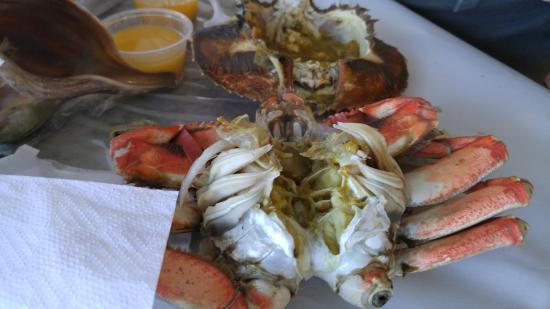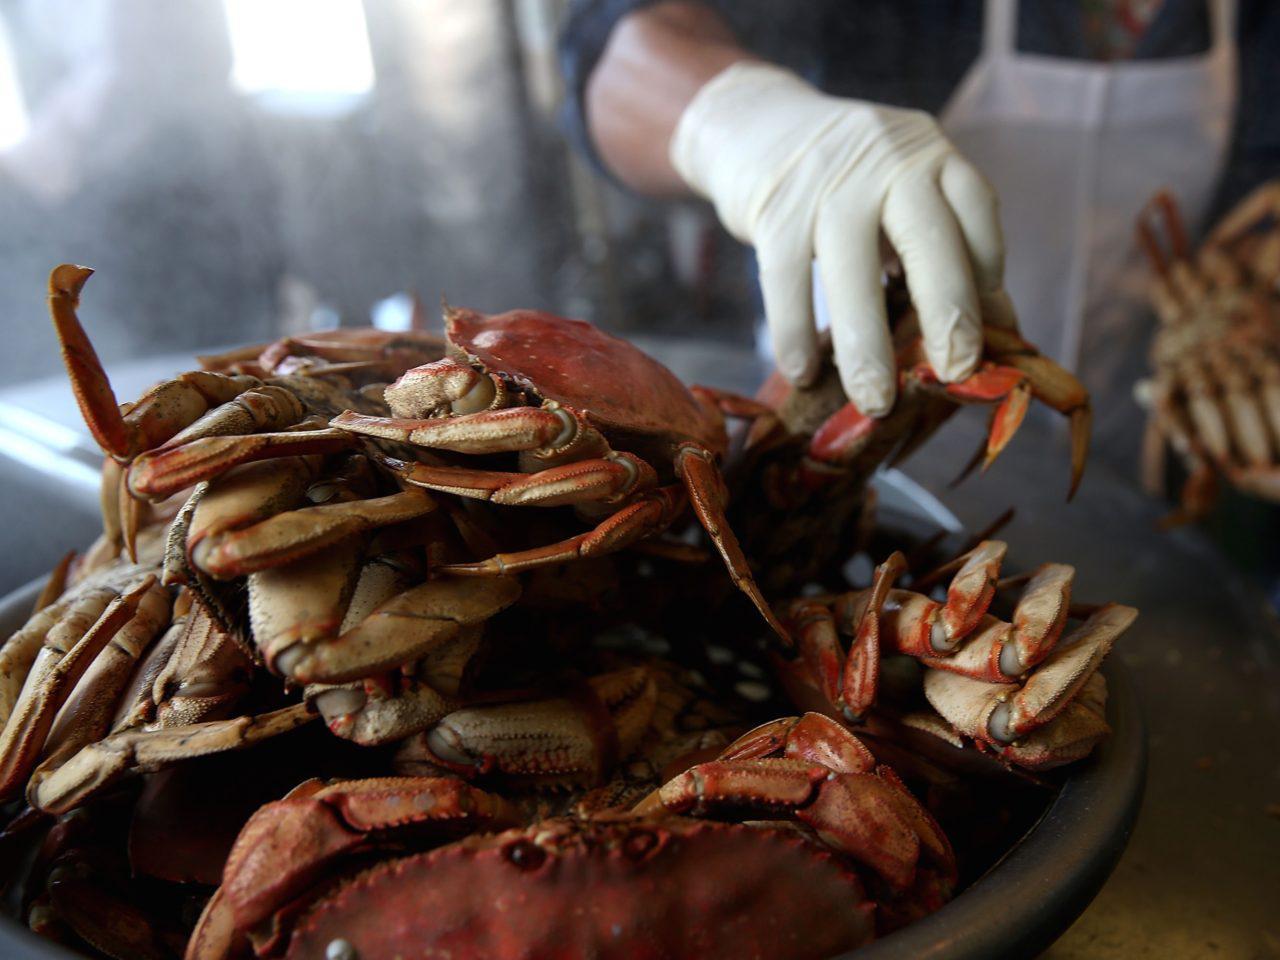The first image is the image on the left, the second image is the image on the right. For the images shown, is this caption "Each image includes a hand near one crab, and one image shows a bare hand grasping a crab and holding it up in front of a body of water." true? Answer yes or no. No. 